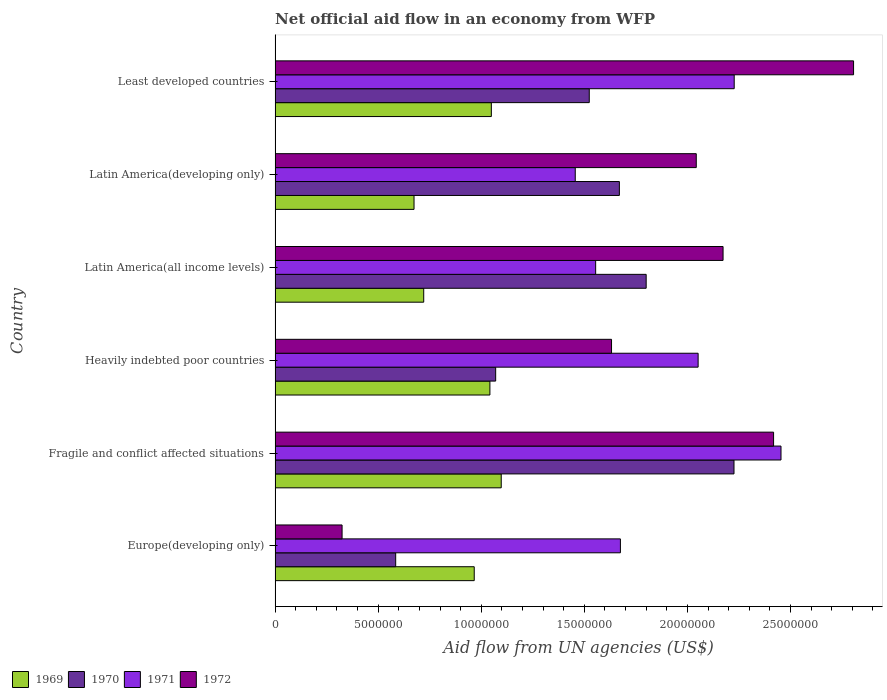How many different coloured bars are there?
Your answer should be very brief. 4. How many groups of bars are there?
Offer a terse response. 6. Are the number of bars per tick equal to the number of legend labels?
Provide a short and direct response. Yes. Are the number of bars on each tick of the Y-axis equal?
Provide a short and direct response. Yes. How many bars are there on the 3rd tick from the top?
Provide a succinct answer. 4. How many bars are there on the 2nd tick from the bottom?
Offer a very short reply. 4. What is the label of the 2nd group of bars from the top?
Make the answer very short. Latin America(developing only). What is the net official aid flow in 1970 in Latin America(developing only)?
Your response must be concise. 1.67e+07. Across all countries, what is the maximum net official aid flow in 1972?
Offer a very short reply. 2.81e+07. Across all countries, what is the minimum net official aid flow in 1970?
Ensure brevity in your answer.  5.85e+06. In which country was the net official aid flow in 1970 maximum?
Make the answer very short. Fragile and conflict affected situations. In which country was the net official aid flow in 1971 minimum?
Ensure brevity in your answer.  Latin America(developing only). What is the total net official aid flow in 1971 in the graph?
Give a very brief answer. 1.14e+08. What is the difference between the net official aid flow in 1970 in Fragile and conflict affected situations and that in Heavily indebted poor countries?
Your answer should be very brief. 1.16e+07. What is the difference between the net official aid flow in 1971 in Heavily indebted poor countries and the net official aid flow in 1972 in Latin America(all income levels)?
Your response must be concise. -1.21e+06. What is the average net official aid flow in 1971 per country?
Offer a very short reply. 1.90e+07. What is the difference between the net official aid flow in 1969 and net official aid flow in 1972 in Fragile and conflict affected situations?
Offer a terse response. -1.32e+07. In how many countries, is the net official aid flow in 1970 greater than 10000000 US$?
Keep it short and to the point. 5. What is the ratio of the net official aid flow in 1971 in Fragile and conflict affected situations to that in Least developed countries?
Your response must be concise. 1.1. Is the net official aid flow in 1970 in Europe(developing only) less than that in Latin America(developing only)?
Provide a succinct answer. Yes. What is the difference between the highest and the second highest net official aid flow in 1970?
Your answer should be compact. 4.26e+06. What is the difference between the highest and the lowest net official aid flow in 1969?
Offer a terse response. 4.23e+06. In how many countries, is the net official aid flow in 1969 greater than the average net official aid flow in 1969 taken over all countries?
Provide a short and direct response. 4. Is it the case that in every country, the sum of the net official aid flow in 1970 and net official aid flow in 1969 is greater than the sum of net official aid flow in 1972 and net official aid flow in 1971?
Make the answer very short. No. What does the 3rd bar from the bottom in Latin America(all income levels) represents?
Provide a succinct answer. 1971. How many countries are there in the graph?
Provide a short and direct response. 6. What is the difference between two consecutive major ticks on the X-axis?
Provide a short and direct response. 5.00e+06. Where does the legend appear in the graph?
Your response must be concise. Bottom left. What is the title of the graph?
Provide a short and direct response. Net official aid flow in an economy from WFP. Does "1986" appear as one of the legend labels in the graph?
Your response must be concise. No. What is the label or title of the X-axis?
Give a very brief answer. Aid flow from UN agencies (US$). What is the label or title of the Y-axis?
Keep it short and to the point. Country. What is the Aid flow from UN agencies (US$) of 1969 in Europe(developing only)?
Your answer should be compact. 9.66e+06. What is the Aid flow from UN agencies (US$) in 1970 in Europe(developing only)?
Provide a short and direct response. 5.85e+06. What is the Aid flow from UN agencies (US$) in 1971 in Europe(developing only)?
Your answer should be very brief. 1.68e+07. What is the Aid flow from UN agencies (US$) in 1972 in Europe(developing only)?
Your answer should be very brief. 3.25e+06. What is the Aid flow from UN agencies (US$) in 1969 in Fragile and conflict affected situations?
Provide a succinct answer. 1.10e+07. What is the Aid flow from UN agencies (US$) of 1970 in Fragile and conflict affected situations?
Provide a succinct answer. 2.23e+07. What is the Aid flow from UN agencies (US$) of 1971 in Fragile and conflict affected situations?
Provide a succinct answer. 2.45e+07. What is the Aid flow from UN agencies (US$) in 1972 in Fragile and conflict affected situations?
Give a very brief answer. 2.42e+07. What is the Aid flow from UN agencies (US$) of 1969 in Heavily indebted poor countries?
Offer a terse response. 1.04e+07. What is the Aid flow from UN agencies (US$) in 1970 in Heavily indebted poor countries?
Your answer should be compact. 1.07e+07. What is the Aid flow from UN agencies (US$) in 1971 in Heavily indebted poor countries?
Provide a succinct answer. 2.05e+07. What is the Aid flow from UN agencies (US$) in 1972 in Heavily indebted poor countries?
Your response must be concise. 1.63e+07. What is the Aid flow from UN agencies (US$) of 1969 in Latin America(all income levels)?
Provide a succinct answer. 7.21e+06. What is the Aid flow from UN agencies (US$) of 1970 in Latin America(all income levels)?
Your answer should be very brief. 1.80e+07. What is the Aid flow from UN agencies (US$) of 1971 in Latin America(all income levels)?
Provide a short and direct response. 1.56e+07. What is the Aid flow from UN agencies (US$) of 1972 in Latin America(all income levels)?
Your answer should be compact. 2.17e+07. What is the Aid flow from UN agencies (US$) of 1969 in Latin America(developing only)?
Give a very brief answer. 6.74e+06. What is the Aid flow from UN agencies (US$) in 1970 in Latin America(developing only)?
Your response must be concise. 1.67e+07. What is the Aid flow from UN agencies (US$) in 1971 in Latin America(developing only)?
Ensure brevity in your answer.  1.46e+07. What is the Aid flow from UN agencies (US$) in 1972 in Latin America(developing only)?
Your answer should be compact. 2.04e+07. What is the Aid flow from UN agencies (US$) in 1969 in Least developed countries?
Your response must be concise. 1.05e+07. What is the Aid flow from UN agencies (US$) of 1970 in Least developed countries?
Keep it short and to the point. 1.52e+07. What is the Aid flow from UN agencies (US$) in 1971 in Least developed countries?
Give a very brief answer. 2.23e+07. What is the Aid flow from UN agencies (US$) in 1972 in Least developed countries?
Ensure brevity in your answer.  2.81e+07. Across all countries, what is the maximum Aid flow from UN agencies (US$) in 1969?
Make the answer very short. 1.10e+07. Across all countries, what is the maximum Aid flow from UN agencies (US$) of 1970?
Your answer should be compact. 2.23e+07. Across all countries, what is the maximum Aid flow from UN agencies (US$) of 1971?
Your answer should be very brief. 2.45e+07. Across all countries, what is the maximum Aid flow from UN agencies (US$) in 1972?
Ensure brevity in your answer.  2.81e+07. Across all countries, what is the minimum Aid flow from UN agencies (US$) of 1969?
Your answer should be very brief. 6.74e+06. Across all countries, what is the minimum Aid flow from UN agencies (US$) of 1970?
Provide a succinct answer. 5.85e+06. Across all countries, what is the minimum Aid flow from UN agencies (US$) of 1971?
Ensure brevity in your answer.  1.46e+07. Across all countries, what is the minimum Aid flow from UN agencies (US$) of 1972?
Provide a short and direct response. 3.25e+06. What is the total Aid flow from UN agencies (US$) of 1969 in the graph?
Keep it short and to the point. 5.55e+07. What is the total Aid flow from UN agencies (US$) in 1970 in the graph?
Your response must be concise. 8.88e+07. What is the total Aid flow from UN agencies (US$) in 1971 in the graph?
Your answer should be very brief. 1.14e+08. What is the total Aid flow from UN agencies (US$) in 1972 in the graph?
Offer a very short reply. 1.14e+08. What is the difference between the Aid flow from UN agencies (US$) in 1969 in Europe(developing only) and that in Fragile and conflict affected situations?
Ensure brevity in your answer.  -1.31e+06. What is the difference between the Aid flow from UN agencies (US$) in 1970 in Europe(developing only) and that in Fragile and conflict affected situations?
Provide a succinct answer. -1.64e+07. What is the difference between the Aid flow from UN agencies (US$) in 1971 in Europe(developing only) and that in Fragile and conflict affected situations?
Make the answer very short. -7.79e+06. What is the difference between the Aid flow from UN agencies (US$) of 1972 in Europe(developing only) and that in Fragile and conflict affected situations?
Give a very brief answer. -2.09e+07. What is the difference between the Aid flow from UN agencies (US$) of 1969 in Europe(developing only) and that in Heavily indebted poor countries?
Your answer should be very brief. -7.60e+05. What is the difference between the Aid flow from UN agencies (US$) in 1970 in Europe(developing only) and that in Heavily indebted poor countries?
Your answer should be very brief. -4.85e+06. What is the difference between the Aid flow from UN agencies (US$) of 1971 in Europe(developing only) and that in Heavily indebted poor countries?
Offer a terse response. -3.77e+06. What is the difference between the Aid flow from UN agencies (US$) in 1972 in Europe(developing only) and that in Heavily indebted poor countries?
Offer a terse response. -1.31e+07. What is the difference between the Aid flow from UN agencies (US$) of 1969 in Europe(developing only) and that in Latin America(all income levels)?
Your answer should be very brief. 2.45e+06. What is the difference between the Aid flow from UN agencies (US$) of 1970 in Europe(developing only) and that in Latin America(all income levels)?
Offer a very short reply. -1.22e+07. What is the difference between the Aid flow from UN agencies (US$) of 1971 in Europe(developing only) and that in Latin America(all income levels)?
Provide a succinct answer. 1.20e+06. What is the difference between the Aid flow from UN agencies (US$) of 1972 in Europe(developing only) and that in Latin America(all income levels)?
Your answer should be very brief. -1.85e+07. What is the difference between the Aid flow from UN agencies (US$) in 1969 in Europe(developing only) and that in Latin America(developing only)?
Provide a succinct answer. 2.92e+06. What is the difference between the Aid flow from UN agencies (US$) of 1970 in Europe(developing only) and that in Latin America(developing only)?
Make the answer very short. -1.08e+07. What is the difference between the Aid flow from UN agencies (US$) of 1971 in Europe(developing only) and that in Latin America(developing only)?
Your answer should be very brief. 2.19e+06. What is the difference between the Aid flow from UN agencies (US$) of 1972 in Europe(developing only) and that in Latin America(developing only)?
Offer a terse response. -1.72e+07. What is the difference between the Aid flow from UN agencies (US$) of 1969 in Europe(developing only) and that in Least developed countries?
Your response must be concise. -8.30e+05. What is the difference between the Aid flow from UN agencies (US$) of 1970 in Europe(developing only) and that in Least developed countries?
Keep it short and to the point. -9.39e+06. What is the difference between the Aid flow from UN agencies (US$) in 1971 in Europe(developing only) and that in Least developed countries?
Make the answer very short. -5.52e+06. What is the difference between the Aid flow from UN agencies (US$) of 1972 in Europe(developing only) and that in Least developed countries?
Provide a short and direct response. -2.48e+07. What is the difference between the Aid flow from UN agencies (US$) in 1970 in Fragile and conflict affected situations and that in Heavily indebted poor countries?
Provide a short and direct response. 1.16e+07. What is the difference between the Aid flow from UN agencies (US$) in 1971 in Fragile and conflict affected situations and that in Heavily indebted poor countries?
Provide a short and direct response. 4.02e+06. What is the difference between the Aid flow from UN agencies (US$) in 1972 in Fragile and conflict affected situations and that in Heavily indebted poor countries?
Keep it short and to the point. 7.86e+06. What is the difference between the Aid flow from UN agencies (US$) of 1969 in Fragile and conflict affected situations and that in Latin America(all income levels)?
Provide a succinct answer. 3.76e+06. What is the difference between the Aid flow from UN agencies (US$) in 1970 in Fragile and conflict affected situations and that in Latin America(all income levels)?
Keep it short and to the point. 4.26e+06. What is the difference between the Aid flow from UN agencies (US$) in 1971 in Fragile and conflict affected situations and that in Latin America(all income levels)?
Provide a succinct answer. 8.99e+06. What is the difference between the Aid flow from UN agencies (US$) of 1972 in Fragile and conflict affected situations and that in Latin America(all income levels)?
Provide a short and direct response. 2.45e+06. What is the difference between the Aid flow from UN agencies (US$) of 1969 in Fragile and conflict affected situations and that in Latin America(developing only)?
Offer a terse response. 4.23e+06. What is the difference between the Aid flow from UN agencies (US$) in 1970 in Fragile and conflict affected situations and that in Latin America(developing only)?
Give a very brief answer. 5.56e+06. What is the difference between the Aid flow from UN agencies (US$) of 1971 in Fragile and conflict affected situations and that in Latin America(developing only)?
Your response must be concise. 9.98e+06. What is the difference between the Aid flow from UN agencies (US$) of 1972 in Fragile and conflict affected situations and that in Latin America(developing only)?
Make the answer very short. 3.75e+06. What is the difference between the Aid flow from UN agencies (US$) in 1970 in Fragile and conflict affected situations and that in Least developed countries?
Your answer should be compact. 7.02e+06. What is the difference between the Aid flow from UN agencies (US$) in 1971 in Fragile and conflict affected situations and that in Least developed countries?
Offer a very short reply. 2.27e+06. What is the difference between the Aid flow from UN agencies (US$) in 1972 in Fragile and conflict affected situations and that in Least developed countries?
Ensure brevity in your answer.  -3.88e+06. What is the difference between the Aid flow from UN agencies (US$) of 1969 in Heavily indebted poor countries and that in Latin America(all income levels)?
Provide a short and direct response. 3.21e+06. What is the difference between the Aid flow from UN agencies (US$) in 1970 in Heavily indebted poor countries and that in Latin America(all income levels)?
Provide a short and direct response. -7.30e+06. What is the difference between the Aid flow from UN agencies (US$) in 1971 in Heavily indebted poor countries and that in Latin America(all income levels)?
Your answer should be compact. 4.97e+06. What is the difference between the Aid flow from UN agencies (US$) in 1972 in Heavily indebted poor countries and that in Latin America(all income levels)?
Give a very brief answer. -5.41e+06. What is the difference between the Aid flow from UN agencies (US$) in 1969 in Heavily indebted poor countries and that in Latin America(developing only)?
Ensure brevity in your answer.  3.68e+06. What is the difference between the Aid flow from UN agencies (US$) of 1970 in Heavily indebted poor countries and that in Latin America(developing only)?
Provide a short and direct response. -6.00e+06. What is the difference between the Aid flow from UN agencies (US$) in 1971 in Heavily indebted poor countries and that in Latin America(developing only)?
Ensure brevity in your answer.  5.96e+06. What is the difference between the Aid flow from UN agencies (US$) of 1972 in Heavily indebted poor countries and that in Latin America(developing only)?
Offer a very short reply. -4.11e+06. What is the difference between the Aid flow from UN agencies (US$) of 1970 in Heavily indebted poor countries and that in Least developed countries?
Keep it short and to the point. -4.54e+06. What is the difference between the Aid flow from UN agencies (US$) in 1971 in Heavily indebted poor countries and that in Least developed countries?
Provide a succinct answer. -1.75e+06. What is the difference between the Aid flow from UN agencies (US$) in 1972 in Heavily indebted poor countries and that in Least developed countries?
Keep it short and to the point. -1.17e+07. What is the difference between the Aid flow from UN agencies (US$) in 1970 in Latin America(all income levels) and that in Latin America(developing only)?
Ensure brevity in your answer.  1.30e+06. What is the difference between the Aid flow from UN agencies (US$) of 1971 in Latin America(all income levels) and that in Latin America(developing only)?
Keep it short and to the point. 9.90e+05. What is the difference between the Aid flow from UN agencies (US$) of 1972 in Latin America(all income levels) and that in Latin America(developing only)?
Offer a very short reply. 1.30e+06. What is the difference between the Aid flow from UN agencies (US$) in 1969 in Latin America(all income levels) and that in Least developed countries?
Offer a very short reply. -3.28e+06. What is the difference between the Aid flow from UN agencies (US$) of 1970 in Latin America(all income levels) and that in Least developed countries?
Keep it short and to the point. 2.76e+06. What is the difference between the Aid flow from UN agencies (US$) of 1971 in Latin America(all income levels) and that in Least developed countries?
Your response must be concise. -6.72e+06. What is the difference between the Aid flow from UN agencies (US$) of 1972 in Latin America(all income levels) and that in Least developed countries?
Offer a terse response. -6.33e+06. What is the difference between the Aid flow from UN agencies (US$) of 1969 in Latin America(developing only) and that in Least developed countries?
Offer a very short reply. -3.75e+06. What is the difference between the Aid flow from UN agencies (US$) of 1970 in Latin America(developing only) and that in Least developed countries?
Ensure brevity in your answer.  1.46e+06. What is the difference between the Aid flow from UN agencies (US$) in 1971 in Latin America(developing only) and that in Least developed countries?
Your response must be concise. -7.71e+06. What is the difference between the Aid flow from UN agencies (US$) in 1972 in Latin America(developing only) and that in Least developed countries?
Your answer should be very brief. -7.63e+06. What is the difference between the Aid flow from UN agencies (US$) in 1969 in Europe(developing only) and the Aid flow from UN agencies (US$) in 1970 in Fragile and conflict affected situations?
Your answer should be compact. -1.26e+07. What is the difference between the Aid flow from UN agencies (US$) of 1969 in Europe(developing only) and the Aid flow from UN agencies (US$) of 1971 in Fragile and conflict affected situations?
Your answer should be very brief. -1.49e+07. What is the difference between the Aid flow from UN agencies (US$) of 1969 in Europe(developing only) and the Aid flow from UN agencies (US$) of 1972 in Fragile and conflict affected situations?
Offer a very short reply. -1.45e+07. What is the difference between the Aid flow from UN agencies (US$) in 1970 in Europe(developing only) and the Aid flow from UN agencies (US$) in 1971 in Fragile and conflict affected situations?
Keep it short and to the point. -1.87e+07. What is the difference between the Aid flow from UN agencies (US$) in 1970 in Europe(developing only) and the Aid flow from UN agencies (US$) in 1972 in Fragile and conflict affected situations?
Your answer should be very brief. -1.83e+07. What is the difference between the Aid flow from UN agencies (US$) of 1971 in Europe(developing only) and the Aid flow from UN agencies (US$) of 1972 in Fragile and conflict affected situations?
Give a very brief answer. -7.43e+06. What is the difference between the Aid flow from UN agencies (US$) in 1969 in Europe(developing only) and the Aid flow from UN agencies (US$) in 1970 in Heavily indebted poor countries?
Give a very brief answer. -1.04e+06. What is the difference between the Aid flow from UN agencies (US$) in 1969 in Europe(developing only) and the Aid flow from UN agencies (US$) in 1971 in Heavily indebted poor countries?
Your answer should be compact. -1.09e+07. What is the difference between the Aid flow from UN agencies (US$) in 1969 in Europe(developing only) and the Aid flow from UN agencies (US$) in 1972 in Heavily indebted poor countries?
Ensure brevity in your answer.  -6.66e+06. What is the difference between the Aid flow from UN agencies (US$) of 1970 in Europe(developing only) and the Aid flow from UN agencies (US$) of 1971 in Heavily indebted poor countries?
Offer a very short reply. -1.47e+07. What is the difference between the Aid flow from UN agencies (US$) of 1970 in Europe(developing only) and the Aid flow from UN agencies (US$) of 1972 in Heavily indebted poor countries?
Provide a succinct answer. -1.05e+07. What is the difference between the Aid flow from UN agencies (US$) in 1969 in Europe(developing only) and the Aid flow from UN agencies (US$) in 1970 in Latin America(all income levels)?
Your response must be concise. -8.34e+06. What is the difference between the Aid flow from UN agencies (US$) in 1969 in Europe(developing only) and the Aid flow from UN agencies (US$) in 1971 in Latin America(all income levels)?
Keep it short and to the point. -5.89e+06. What is the difference between the Aid flow from UN agencies (US$) in 1969 in Europe(developing only) and the Aid flow from UN agencies (US$) in 1972 in Latin America(all income levels)?
Ensure brevity in your answer.  -1.21e+07. What is the difference between the Aid flow from UN agencies (US$) of 1970 in Europe(developing only) and the Aid flow from UN agencies (US$) of 1971 in Latin America(all income levels)?
Keep it short and to the point. -9.70e+06. What is the difference between the Aid flow from UN agencies (US$) in 1970 in Europe(developing only) and the Aid flow from UN agencies (US$) in 1972 in Latin America(all income levels)?
Give a very brief answer. -1.59e+07. What is the difference between the Aid flow from UN agencies (US$) of 1971 in Europe(developing only) and the Aid flow from UN agencies (US$) of 1972 in Latin America(all income levels)?
Keep it short and to the point. -4.98e+06. What is the difference between the Aid flow from UN agencies (US$) in 1969 in Europe(developing only) and the Aid flow from UN agencies (US$) in 1970 in Latin America(developing only)?
Provide a short and direct response. -7.04e+06. What is the difference between the Aid flow from UN agencies (US$) in 1969 in Europe(developing only) and the Aid flow from UN agencies (US$) in 1971 in Latin America(developing only)?
Your answer should be compact. -4.90e+06. What is the difference between the Aid flow from UN agencies (US$) in 1969 in Europe(developing only) and the Aid flow from UN agencies (US$) in 1972 in Latin America(developing only)?
Your response must be concise. -1.08e+07. What is the difference between the Aid flow from UN agencies (US$) in 1970 in Europe(developing only) and the Aid flow from UN agencies (US$) in 1971 in Latin America(developing only)?
Keep it short and to the point. -8.71e+06. What is the difference between the Aid flow from UN agencies (US$) in 1970 in Europe(developing only) and the Aid flow from UN agencies (US$) in 1972 in Latin America(developing only)?
Provide a short and direct response. -1.46e+07. What is the difference between the Aid flow from UN agencies (US$) of 1971 in Europe(developing only) and the Aid flow from UN agencies (US$) of 1972 in Latin America(developing only)?
Give a very brief answer. -3.68e+06. What is the difference between the Aid flow from UN agencies (US$) in 1969 in Europe(developing only) and the Aid flow from UN agencies (US$) in 1970 in Least developed countries?
Provide a succinct answer. -5.58e+06. What is the difference between the Aid flow from UN agencies (US$) of 1969 in Europe(developing only) and the Aid flow from UN agencies (US$) of 1971 in Least developed countries?
Offer a terse response. -1.26e+07. What is the difference between the Aid flow from UN agencies (US$) in 1969 in Europe(developing only) and the Aid flow from UN agencies (US$) in 1972 in Least developed countries?
Ensure brevity in your answer.  -1.84e+07. What is the difference between the Aid flow from UN agencies (US$) of 1970 in Europe(developing only) and the Aid flow from UN agencies (US$) of 1971 in Least developed countries?
Give a very brief answer. -1.64e+07. What is the difference between the Aid flow from UN agencies (US$) of 1970 in Europe(developing only) and the Aid flow from UN agencies (US$) of 1972 in Least developed countries?
Keep it short and to the point. -2.22e+07. What is the difference between the Aid flow from UN agencies (US$) in 1971 in Europe(developing only) and the Aid flow from UN agencies (US$) in 1972 in Least developed countries?
Provide a short and direct response. -1.13e+07. What is the difference between the Aid flow from UN agencies (US$) in 1969 in Fragile and conflict affected situations and the Aid flow from UN agencies (US$) in 1971 in Heavily indebted poor countries?
Ensure brevity in your answer.  -9.55e+06. What is the difference between the Aid flow from UN agencies (US$) of 1969 in Fragile and conflict affected situations and the Aid flow from UN agencies (US$) of 1972 in Heavily indebted poor countries?
Offer a terse response. -5.35e+06. What is the difference between the Aid flow from UN agencies (US$) in 1970 in Fragile and conflict affected situations and the Aid flow from UN agencies (US$) in 1971 in Heavily indebted poor countries?
Make the answer very short. 1.74e+06. What is the difference between the Aid flow from UN agencies (US$) of 1970 in Fragile and conflict affected situations and the Aid flow from UN agencies (US$) of 1972 in Heavily indebted poor countries?
Your answer should be very brief. 5.94e+06. What is the difference between the Aid flow from UN agencies (US$) of 1971 in Fragile and conflict affected situations and the Aid flow from UN agencies (US$) of 1972 in Heavily indebted poor countries?
Keep it short and to the point. 8.22e+06. What is the difference between the Aid flow from UN agencies (US$) of 1969 in Fragile and conflict affected situations and the Aid flow from UN agencies (US$) of 1970 in Latin America(all income levels)?
Keep it short and to the point. -7.03e+06. What is the difference between the Aid flow from UN agencies (US$) in 1969 in Fragile and conflict affected situations and the Aid flow from UN agencies (US$) in 1971 in Latin America(all income levels)?
Provide a short and direct response. -4.58e+06. What is the difference between the Aid flow from UN agencies (US$) of 1969 in Fragile and conflict affected situations and the Aid flow from UN agencies (US$) of 1972 in Latin America(all income levels)?
Provide a succinct answer. -1.08e+07. What is the difference between the Aid flow from UN agencies (US$) of 1970 in Fragile and conflict affected situations and the Aid flow from UN agencies (US$) of 1971 in Latin America(all income levels)?
Offer a terse response. 6.71e+06. What is the difference between the Aid flow from UN agencies (US$) of 1970 in Fragile and conflict affected situations and the Aid flow from UN agencies (US$) of 1972 in Latin America(all income levels)?
Offer a very short reply. 5.30e+05. What is the difference between the Aid flow from UN agencies (US$) in 1971 in Fragile and conflict affected situations and the Aid flow from UN agencies (US$) in 1972 in Latin America(all income levels)?
Provide a short and direct response. 2.81e+06. What is the difference between the Aid flow from UN agencies (US$) of 1969 in Fragile and conflict affected situations and the Aid flow from UN agencies (US$) of 1970 in Latin America(developing only)?
Your response must be concise. -5.73e+06. What is the difference between the Aid flow from UN agencies (US$) of 1969 in Fragile and conflict affected situations and the Aid flow from UN agencies (US$) of 1971 in Latin America(developing only)?
Keep it short and to the point. -3.59e+06. What is the difference between the Aid flow from UN agencies (US$) in 1969 in Fragile and conflict affected situations and the Aid flow from UN agencies (US$) in 1972 in Latin America(developing only)?
Make the answer very short. -9.46e+06. What is the difference between the Aid flow from UN agencies (US$) in 1970 in Fragile and conflict affected situations and the Aid flow from UN agencies (US$) in 1971 in Latin America(developing only)?
Your response must be concise. 7.70e+06. What is the difference between the Aid flow from UN agencies (US$) in 1970 in Fragile and conflict affected situations and the Aid flow from UN agencies (US$) in 1972 in Latin America(developing only)?
Ensure brevity in your answer.  1.83e+06. What is the difference between the Aid flow from UN agencies (US$) of 1971 in Fragile and conflict affected situations and the Aid flow from UN agencies (US$) of 1972 in Latin America(developing only)?
Your answer should be very brief. 4.11e+06. What is the difference between the Aid flow from UN agencies (US$) of 1969 in Fragile and conflict affected situations and the Aid flow from UN agencies (US$) of 1970 in Least developed countries?
Your answer should be very brief. -4.27e+06. What is the difference between the Aid flow from UN agencies (US$) in 1969 in Fragile and conflict affected situations and the Aid flow from UN agencies (US$) in 1971 in Least developed countries?
Your answer should be very brief. -1.13e+07. What is the difference between the Aid flow from UN agencies (US$) in 1969 in Fragile and conflict affected situations and the Aid flow from UN agencies (US$) in 1972 in Least developed countries?
Ensure brevity in your answer.  -1.71e+07. What is the difference between the Aid flow from UN agencies (US$) of 1970 in Fragile and conflict affected situations and the Aid flow from UN agencies (US$) of 1971 in Least developed countries?
Ensure brevity in your answer.  -10000. What is the difference between the Aid flow from UN agencies (US$) in 1970 in Fragile and conflict affected situations and the Aid flow from UN agencies (US$) in 1972 in Least developed countries?
Your answer should be very brief. -5.80e+06. What is the difference between the Aid flow from UN agencies (US$) of 1971 in Fragile and conflict affected situations and the Aid flow from UN agencies (US$) of 1972 in Least developed countries?
Provide a short and direct response. -3.52e+06. What is the difference between the Aid flow from UN agencies (US$) in 1969 in Heavily indebted poor countries and the Aid flow from UN agencies (US$) in 1970 in Latin America(all income levels)?
Offer a very short reply. -7.58e+06. What is the difference between the Aid flow from UN agencies (US$) of 1969 in Heavily indebted poor countries and the Aid flow from UN agencies (US$) of 1971 in Latin America(all income levels)?
Provide a succinct answer. -5.13e+06. What is the difference between the Aid flow from UN agencies (US$) of 1969 in Heavily indebted poor countries and the Aid flow from UN agencies (US$) of 1972 in Latin America(all income levels)?
Offer a terse response. -1.13e+07. What is the difference between the Aid flow from UN agencies (US$) of 1970 in Heavily indebted poor countries and the Aid flow from UN agencies (US$) of 1971 in Latin America(all income levels)?
Provide a succinct answer. -4.85e+06. What is the difference between the Aid flow from UN agencies (US$) of 1970 in Heavily indebted poor countries and the Aid flow from UN agencies (US$) of 1972 in Latin America(all income levels)?
Your answer should be very brief. -1.10e+07. What is the difference between the Aid flow from UN agencies (US$) in 1971 in Heavily indebted poor countries and the Aid flow from UN agencies (US$) in 1972 in Latin America(all income levels)?
Provide a short and direct response. -1.21e+06. What is the difference between the Aid flow from UN agencies (US$) in 1969 in Heavily indebted poor countries and the Aid flow from UN agencies (US$) in 1970 in Latin America(developing only)?
Offer a terse response. -6.28e+06. What is the difference between the Aid flow from UN agencies (US$) in 1969 in Heavily indebted poor countries and the Aid flow from UN agencies (US$) in 1971 in Latin America(developing only)?
Make the answer very short. -4.14e+06. What is the difference between the Aid flow from UN agencies (US$) of 1969 in Heavily indebted poor countries and the Aid flow from UN agencies (US$) of 1972 in Latin America(developing only)?
Provide a short and direct response. -1.00e+07. What is the difference between the Aid flow from UN agencies (US$) of 1970 in Heavily indebted poor countries and the Aid flow from UN agencies (US$) of 1971 in Latin America(developing only)?
Your response must be concise. -3.86e+06. What is the difference between the Aid flow from UN agencies (US$) in 1970 in Heavily indebted poor countries and the Aid flow from UN agencies (US$) in 1972 in Latin America(developing only)?
Your response must be concise. -9.73e+06. What is the difference between the Aid flow from UN agencies (US$) of 1971 in Heavily indebted poor countries and the Aid flow from UN agencies (US$) of 1972 in Latin America(developing only)?
Give a very brief answer. 9.00e+04. What is the difference between the Aid flow from UN agencies (US$) of 1969 in Heavily indebted poor countries and the Aid flow from UN agencies (US$) of 1970 in Least developed countries?
Ensure brevity in your answer.  -4.82e+06. What is the difference between the Aid flow from UN agencies (US$) in 1969 in Heavily indebted poor countries and the Aid flow from UN agencies (US$) in 1971 in Least developed countries?
Ensure brevity in your answer.  -1.18e+07. What is the difference between the Aid flow from UN agencies (US$) of 1969 in Heavily indebted poor countries and the Aid flow from UN agencies (US$) of 1972 in Least developed countries?
Provide a short and direct response. -1.76e+07. What is the difference between the Aid flow from UN agencies (US$) of 1970 in Heavily indebted poor countries and the Aid flow from UN agencies (US$) of 1971 in Least developed countries?
Your answer should be compact. -1.16e+07. What is the difference between the Aid flow from UN agencies (US$) in 1970 in Heavily indebted poor countries and the Aid flow from UN agencies (US$) in 1972 in Least developed countries?
Your answer should be compact. -1.74e+07. What is the difference between the Aid flow from UN agencies (US$) of 1971 in Heavily indebted poor countries and the Aid flow from UN agencies (US$) of 1972 in Least developed countries?
Provide a short and direct response. -7.54e+06. What is the difference between the Aid flow from UN agencies (US$) of 1969 in Latin America(all income levels) and the Aid flow from UN agencies (US$) of 1970 in Latin America(developing only)?
Give a very brief answer. -9.49e+06. What is the difference between the Aid flow from UN agencies (US$) of 1969 in Latin America(all income levels) and the Aid flow from UN agencies (US$) of 1971 in Latin America(developing only)?
Keep it short and to the point. -7.35e+06. What is the difference between the Aid flow from UN agencies (US$) in 1969 in Latin America(all income levels) and the Aid flow from UN agencies (US$) in 1972 in Latin America(developing only)?
Ensure brevity in your answer.  -1.32e+07. What is the difference between the Aid flow from UN agencies (US$) of 1970 in Latin America(all income levels) and the Aid flow from UN agencies (US$) of 1971 in Latin America(developing only)?
Make the answer very short. 3.44e+06. What is the difference between the Aid flow from UN agencies (US$) of 1970 in Latin America(all income levels) and the Aid flow from UN agencies (US$) of 1972 in Latin America(developing only)?
Offer a very short reply. -2.43e+06. What is the difference between the Aid flow from UN agencies (US$) in 1971 in Latin America(all income levels) and the Aid flow from UN agencies (US$) in 1972 in Latin America(developing only)?
Your answer should be very brief. -4.88e+06. What is the difference between the Aid flow from UN agencies (US$) in 1969 in Latin America(all income levels) and the Aid flow from UN agencies (US$) in 1970 in Least developed countries?
Offer a terse response. -8.03e+06. What is the difference between the Aid flow from UN agencies (US$) in 1969 in Latin America(all income levels) and the Aid flow from UN agencies (US$) in 1971 in Least developed countries?
Your answer should be compact. -1.51e+07. What is the difference between the Aid flow from UN agencies (US$) in 1969 in Latin America(all income levels) and the Aid flow from UN agencies (US$) in 1972 in Least developed countries?
Provide a short and direct response. -2.08e+07. What is the difference between the Aid flow from UN agencies (US$) in 1970 in Latin America(all income levels) and the Aid flow from UN agencies (US$) in 1971 in Least developed countries?
Give a very brief answer. -4.27e+06. What is the difference between the Aid flow from UN agencies (US$) of 1970 in Latin America(all income levels) and the Aid flow from UN agencies (US$) of 1972 in Least developed countries?
Offer a terse response. -1.01e+07. What is the difference between the Aid flow from UN agencies (US$) in 1971 in Latin America(all income levels) and the Aid flow from UN agencies (US$) in 1972 in Least developed countries?
Offer a very short reply. -1.25e+07. What is the difference between the Aid flow from UN agencies (US$) of 1969 in Latin America(developing only) and the Aid flow from UN agencies (US$) of 1970 in Least developed countries?
Your answer should be very brief. -8.50e+06. What is the difference between the Aid flow from UN agencies (US$) of 1969 in Latin America(developing only) and the Aid flow from UN agencies (US$) of 1971 in Least developed countries?
Keep it short and to the point. -1.55e+07. What is the difference between the Aid flow from UN agencies (US$) of 1969 in Latin America(developing only) and the Aid flow from UN agencies (US$) of 1972 in Least developed countries?
Your answer should be compact. -2.13e+07. What is the difference between the Aid flow from UN agencies (US$) of 1970 in Latin America(developing only) and the Aid flow from UN agencies (US$) of 1971 in Least developed countries?
Ensure brevity in your answer.  -5.57e+06. What is the difference between the Aid flow from UN agencies (US$) in 1970 in Latin America(developing only) and the Aid flow from UN agencies (US$) in 1972 in Least developed countries?
Give a very brief answer. -1.14e+07. What is the difference between the Aid flow from UN agencies (US$) of 1971 in Latin America(developing only) and the Aid flow from UN agencies (US$) of 1972 in Least developed countries?
Provide a succinct answer. -1.35e+07. What is the average Aid flow from UN agencies (US$) in 1969 per country?
Ensure brevity in your answer.  9.25e+06. What is the average Aid flow from UN agencies (US$) of 1970 per country?
Keep it short and to the point. 1.48e+07. What is the average Aid flow from UN agencies (US$) in 1971 per country?
Make the answer very short. 1.90e+07. What is the average Aid flow from UN agencies (US$) of 1972 per country?
Give a very brief answer. 1.90e+07. What is the difference between the Aid flow from UN agencies (US$) of 1969 and Aid flow from UN agencies (US$) of 1970 in Europe(developing only)?
Your answer should be very brief. 3.81e+06. What is the difference between the Aid flow from UN agencies (US$) in 1969 and Aid flow from UN agencies (US$) in 1971 in Europe(developing only)?
Your answer should be compact. -7.09e+06. What is the difference between the Aid flow from UN agencies (US$) of 1969 and Aid flow from UN agencies (US$) of 1972 in Europe(developing only)?
Provide a succinct answer. 6.41e+06. What is the difference between the Aid flow from UN agencies (US$) in 1970 and Aid flow from UN agencies (US$) in 1971 in Europe(developing only)?
Provide a succinct answer. -1.09e+07. What is the difference between the Aid flow from UN agencies (US$) of 1970 and Aid flow from UN agencies (US$) of 1972 in Europe(developing only)?
Ensure brevity in your answer.  2.60e+06. What is the difference between the Aid flow from UN agencies (US$) in 1971 and Aid flow from UN agencies (US$) in 1972 in Europe(developing only)?
Keep it short and to the point. 1.35e+07. What is the difference between the Aid flow from UN agencies (US$) in 1969 and Aid flow from UN agencies (US$) in 1970 in Fragile and conflict affected situations?
Your answer should be compact. -1.13e+07. What is the difference between the Aid flow from UN agencies (US$) of 1969 and Aid flow from UN agencies (US$) of 1971 in Fragile and conflict affected situations?
Ensure brevity in your answer.  -1.36e+07. What is the difference between the Aid flow from UN agencies (US$) in 1969 and Aid flow from UN agencies (US$) in 1972 in Fragile and conflict affected situations?
Give a very brief answer. -1.32e+07. What is the difference between the Aid flow from UN agencies (US$) of 1970 and Aid flow from UN agencies (US$) of 1971 in Fragile and conflict affected situations?
Ensure brevity in your answer.  -2.28e+06. What is the difference between the Aid flow from UN agencies (US$) in 1970 and Aid flow from UN agencies (US$) in 1972 in Fragile and conflict affected situations?
Provide a short and direct response. -1.92e+06. What is the difference between the Aid flow from UN agencies (US$) of 1969 and Aid flow from UN agencies (US$) of 1970 in Heavily indebted poor countries?
Offer a terse response. -2.80e+05. What is the difference between the Aid flow from UN agencies (US$) of 1969 and Aid flow from UN agencies (US$) of 1971 in Heavily indebted poor countries?
Keep it short and to the point. -1.01e+07. What is the difference between the Aid flow from UN agencies (US$) in 1969 and Aid flow from UN agencies (US$) in 1972 in Heavily indebted poor countries?
Offer a very short reply. -5.90e+06. What is the difference between the Aid flow from UN agencies (US$) of 1970 and Aid flow from UN agencies (US$) of 1971 in Heavily indebted poor countries?
Your answer should be compact. -9.82e+06. What is the difference between the Aid flow from UN agencies (US$) in 1970 and Aid flow from UN agencies (US$) in 1972 in Heavily indebted poor countries?
Provide a short and direct response. -5.62e+06. What is the difference between the Aid flow from UN agencies (US$) of 1971 and Aid flow from UN agencies (US$) of 1972 in Heavily indebted poor countries?
Your response must be concise. 4.20e+06. What is the difference between the Aid flow from UN agencies (US$) in 1969 and Aid flow from UN agencies (US$) in 1970 in Latin America(all income levels)?
Provide a short and direct response. -1.08e+07. What is the difference between the Aid flow from UN agencies (US$) in 1969 and Aid flow from UN agencies (US$) in 1971 in Latin America(all income levels)?
Provide a succinct answer. -8.34e+06. What is the difference between the Aid flow from UN agencies (US$) of 1969 and Aid flow from UN agencies (US$) of 1972 in Latin America(all income levels)?
Offer a very short reply. -1.45e+07. What is the difference between the Aid flow from UN agencies (US$) in 1970 and Aid flow from UN agencies (US$) in 1971 in Latin America(all income levels)?
Give a very brief answer. 2.45e+06. What is the difference between the Aid flow from UN agencies (US$) of 1970 and Aid flow from UN agencies (US$) of 1972 in Latin America(all income levels)?
Make the answer very short. -3.73e+06. What is the difference between the Aid flow from UN agencies (US$) of 1971 and Aid flow from UN agencies (US$) of 1972 in Latin America(all income levels)?
Ensure brevity in your answer.  -6.18e+06. What is the difference between the Aid flow from UN agencies (US$) in 1969 and Aid flow from UN agencies (US$) in 1970 in Latin America(developing only)?
Your answer should be very brief. -9.96e+06. What is the difference between the Aid flow from UN agencies (US$) in 1969 and Aid flow from UN agencies (US$) in 1971 in Latin America(developing only)?
Make the answer very short. -7.82e+06. What is the difference between the Aid flow from UN agencies (US$) of 1969 and Aid flow from UN agencies (US$) of 1972 in Latin America(developing only)?
Give a very brief answer. -1.37e+07. What is the difference between the Aid flow from UN agencies (US$) of 1970 and Aid flow from UN agencies (US$) of 1971 in Latin America(developing only)?
Your answer should be compact. 2.14e+06. What is the difference between the Aid flow from UN agencies (US$) in 1970 and Aid flow from UN agencies (US$) in 1972 in Latin America(developing only)?
Your answer should be very brief. -3.73e+06. What is the difference between the Aid flow from UN agencies (US$) of 1971 and Aid flow from UN agencies (US$) of 1972 in Latin America(developing only)?
Keep it short and to the point. -5.87e+06. What is the difference between the Aid flow from UN agencies (US$) of 1969 and Aid flow from UN agencies (US$) of 1970 in Least developed countries?
Ensure brevity in your answer.  -4.75e+06. What is the difference between the Aid flow from UN agencies (US$) in 1969 and Aid flow from UN agencies (US$) in 1971 in Least developed countries?
Make the answer very short. -1.18e+07. What is the difference between the Aid flow from UN agencies (US$) in 1969 and Aid flow from UN agencies (US$) in 1972 in Least developed countries?
Your answer should be very brief. -1.76e+07. What is the difference between the Aid flow from UN agencies (US$) of 1970 and Aid flow from UN agencies (US$) of 1971 in Least developed countries?
Provide a succinct answer. -7.03e+06. What is the difference between the Aid flow from UN agencies (US$) of 1970 and Aid flow from UN agencies (US$) of 1972 in Least developed countries?
Provide a short and direct response. -1.28e+07. What is the difference between the Aid flow from UN agencies (US$) in 1971 and Aid flow from UN agencies (US$) in 1972 in Least developed countries?
Offer a terse response. -5.79e+06. What is the ratio of the Aid flow from UN agencies (US$) in 1969 in Europe(developing only) to that in Fragile and conflict affected situations?
Offer a very short reply. 0.88. What is the ratio of the Aid flow from UN agencies (US$) in 1970 in Europe(developing only) to that in Fragile and conflict affected situations?
Provide a succinct answer. 0.26. What is the ratio of the Aid flow from UN agencies (US$) in 1971 in Europe(developing only) to that in Fragile and conflict affected situations?
Ensure brevity in your answer.  0.68. What is the ratio of the Aid flow from UN agencies (US$) in 1972 in Europe(developing only) to that in Fragile and conflict affected situations?
Your answer should be compact. 0.13. What is the ratio of the Aid flow from UN agencies (US$) in 1969 in Europe(developing only) to that in Heavily indebted poor countries?
Your response must be concise. 0.93. What is the ratio of the Aid flow from UN agencies (US$) of 1970 in Europe(developing only) to that in Heavily indebted poor countries?
Give a very brief answer. 0.55. What is the ratio of the Aid flow from UN agencies (US$) of 1971 in Europe(developing only) to that in Heavily indebted poor countries?
Provide a succinct answer. 0.82. What is the ratio of the Aid flow from UN agencies (US$) in 1972 in Europe(developing only) to that in Heavily indebted poor countries?
Make the answer very short. 0.2. What is the ratio of the Aid flow from UN agencies (US$) of 1969 in Europe(developing only) to that in Latin America(all income levels)?
Provide a short and direct response. 1.34. What is the ratio of the Aid flow from UN agencies (US$) in 1970 in Europe(developing only) to that in Latin America(all income levels)?
Keep it short and to the point. 0.33. What is the ratio of the Aid flow from UN agencies (US$) in 1971 in Europe(developing only) to that in Latin America(all income levels)?
Give a very brief answer. 1.08. What is the ratio of the Aid flow from UN agencies (US$) in 1972 in Europe(developing only) to that in Latin America(all income levels)?
Ensure brevity in your answer.  0.15. What is the ratio of the Aid flow from UN agencies (US$) of 1969 in Europe(developing only) to that in Latin America(developing only)?
Your answer should be compact. 1.43. What is the ratio of the Aid flow from UN agencies (US$) in 1970 in Europe(developing only) to that in Latin America(developing only)?
Provide a short and direct response. 0.35. What is the ratio of the Aid flow from UN agencies (US$) in 1971 in Europe(developing only) to that in Latin America(developing only)?
Offer a very short reply. 1.15. What is the ratio of the Aid flow from UN agencies (US$) of 1972 in Europe(developing only) to that in Latin America(developing only)?
Keep it short and to the point. 0.16. What is the ratio of the Aid flow from UN agencies (US$) in 1969 in Europe(developing only) to that in Least developed countries?
Your answer should be compact. 0.92. What is the ratio of the Aid flow from UN agencies (US$) in 1970 in Europe(developing only) to that in Least developed countries?
Keep it short and to the point. 0.38. What is the ratio of the Aid flow from UN agencies (US$) of 1971 in Europe(developing only) to that in Least developed countries?
Your answer should be very brief. 0.75. What is the ratio of the Aid flow from UN agencies (US$) in 1972 in Europe(developing only) to that in Least developed countries?
Offer a very short reply. 0.12. What is the ratio of the Aid flow from UN agencies (US$) of 1969 in Fragile and conflict affected situations to that in Heavily indebted poor countries?
Give a very brief answer. 1.05. What is the ratio of the Aid flow from UN agencies (US$) of 1970 in Fragile and conflict affected situations to that in Heavily indebted poor countries?
Offer a terse response. 2.08. What is the ratio of the Aid flow from UN agencies (US$) in 1971 in Fragile and conflict affected situations to that in Heavily indebted poor countries?
Ensure brevity in your answer.  1.2. What is the ratio of the Aid flow from UN agencies (US$) of 1972 in Fragile and conflict affected situations to that in Heavily indebted poor countries?
Provide a short and direct response. 1.48. What is the ratio of the Aid flow from UN agencies (US$) in 1969 in Fragile and conflict affected situations to that in Latin America(all income levels)?
Your answer should be very brief. 1.52. What is the ratio of the Aid flow from UN agencies (US$) in 1970 in Fragile and conflict affected situations to that in Latin America(all income levels)?
Provide a succinct answer. 1.24. What is the ratio of the Aid flow from UN agencies (US$) of 1971 in Fragile and conflict affected situations to that in Latin America(all income levels)?
Keep it short and to the point. 1.58. What is the ratio of the Aid flow from UN agencies (US$) of 1972 in Fragile and conflict affected situations to that in Latin America(all income levels)?
Give a very brief answer. 1.11. What is the ratio of the Aid flow from UN agencies (US$) in 1969 in Fragile and conflict affected situations to that in Latin America(developing only)?
Your answer should be compact. 1.63. What is the ratio of the Aid flow from UN agencies (US$) in 1970 in Fragile and conflict affected situations to that in Latin America(developing only)?
Offer a terse response. 1.33. What is the ratio of the Aid flow from UN agencies (US$) of 1971 in Fragile and conflict affected situations to that in Latin America(developing only)?
Offer a terse response. 1.69. What is the ratio of the Aid flow from UN agencies (US$) of 1972 in Fragile and conflict affected situations to that in Latin America(developing only)?
Offer a very short reply. 1.18. What is the ratio of the Aid flow from UN agencies (US$) of 1969 in Fragile and conflict affected situations to that in Least developed countries?
Offer a very short reply. 1.05. What is the ratio of the Aid flow from UN agencies (US$) of 1970 in Fragile and conflict affected situations to that in Least developed countries?
Provide a succinct answer. 1.46. What is the ratio of the Aid flow from UN agencies (US$) of 1971 in Fragile and conflict affected situations to that in Least developed countries?
Keep it short and to the point. 1.1. What is the ratio of the Aid flow from UN agencies (US$) in 1972 in Fragile and conflict affected situations to that in Least developed countries?
Your answer should be compact. 0.86. What is the ratio of the Aid flow from UN agencies (US$) of 1969 in Heavily indebted poor countries to that in Latin America(all income levels)?
Your response must be concise. 1.45. What is the ratio of the Aid flow from UN agencies (US$) of 1970 in Heavily indebted poor countries to that in Latin America(all income levels)?
Make the answer very short. 0.59. What is the ratio of the Aid flow from UN agencies (US$) in 1971 in Heavily indebted poor countries to that in Latin America(all income levels)?
Your answer should be compact. 1.32. What is the ratio of the Aid flow from UN agencies (US$) in 1972 in Heavily indebted poor countries to that in Latin America(all income levels)?
Your answer should be compact. 0.75. What is the ratio of the Aid flow from UN agencies (US$) of 1969 in Heavily indebted poor countries to that in Latin America(developing only)?
Make the answer very short. 1.55. What is the ratio of the Aid flow from UN agencies (US$) of 1970 in Heavily indebted poor countries to that in Latin America(developing only)?
Offer a terse response. 0.64. What is the ratio of the Aid flow from UN agencies (US$) of 1971 in Heavily indebted poor countries to that in Latin America(developing only)?
Keep it short and to the point. 1.41. What is the ratio of the Aid flow from UN agencies (US$) of 1972 in Heavily indebted poor countries to that in Latin America(developing only)?
Your response must be concise. 0.8. What is the ratio of the Aid flow from UN agencies (US$) in 1969 in Heavily indebted poor countries to that in Least developed countries?
Give a very brief answer. 0.99. What is the ratio of the Aid flow from UN agencies (US$) in 1970 in Heavily indebted poor countries to that in Least developed countries?
Offer a very short reply. 0.7. What is the ratio of the Aid flow from UN agencies (US$) of 1971 in Heavily indebted poor countries to that in Least developed countries?
Provide a short and direct response. 0.92. What is the ratio of the Aid flow from UN agencies (US$) in 1972 in Heavily indebted poor countries to that in Least developed countries?
Make the answer very short. 0.58. What is the ratio of the Aid flow from UN agencies (US$) of 1969 in Latin America(all income levels) to that in Latin America(developing only)?
Provide a short and direct response. 1.07. What is the ratio of the Aid flow from UN agencies (US$) in 1970 in Latin America(all income levels) to that in Latin America(developing only)?
Your answer should be very brief. 1.08. What is the ratio of the Aid flow from UN agencies (US$) of 1971 in Latin America(all income levels) to that in Latin America(developing only)?
Provide a short and direct response. 1.07. What is the ratio of the Aid flow from UN agencies (US$) in 1972 in Latin America(all income levels) to that in Latin America(developing only)?
Your answer should be compact. 1.06. What is the ratio of the Aid flow from UN agencies (US$) of 1969 in Latin America(all income levels) to that in Least developed countries?
Give a very brief answer. 0.69. What is the ratio of the Aid flow from UN agencies (US$) of 1970 in Latin America(all income levels) to that in Least developed countries?
Make the answer very short. 1.18. What is the ratio of the Aid flow from UN agencies (US$) in 1971 in Latin America(all income levels) to that in Least developed countries?
Ensure brevity in your answer.  0.7. What is the ratio of the Aid flow from UN agencies (US$) of 1972 in Latin America(all income levels) to that in Least developed countries?
Your answer should be compact. 0.77. What is the ratio of the Aid flow from UN agencies (US$) in 1969 in Latin America(developing only) to that in Least developed countries?
Offer a terse response. 0.64. What is the ratio of the Aid flow from UN agencies (US$) of 1970 in Latin America(developing only) to that in Least developed countries?
Provide a succinct answer. 1.1. What is the ratio of the Aid flow from UN agencies (US$) in 1971 in Latin America(developing only) to that in Least developed countries?
Provide a succinct answer. 0.65. What is the ratio of the Aid flow from UN agencies (US$) in 1972 in Latin America(developing only) to that in Least developed countries?
Your answer should be compact. 0.73. What is the difference between the highest and the second highest Aid flow from UN agencies (US$) in 1970?
Provide a succinct answer. 4.26e+06. What is the difference between the highest and the second highest Aid flow from UN agencies (US$) in 1971?
Ensure brevity in your answer.  2.27e+06. What is the difference between the highest and the second highest Aid flow from UN agencies (US$) in 1972?
Your answer should be very brief. 3.88e+06. What is the difference between the highest and the lowest Aid flow from UN agencies (US$) in 1969?
Your answer should be very brief. 4.23e+06. What is the difference between the highest and the lowest Aid flow from UN agencies (US$) of 1970?
Keep it short and to the point. 1.64e+07. What is the difference between the highest and the lowest Aid flow from UN agencies (US$) of 1971?
Offer a terse response. 9.98e+06. What is the difference between the highest and the lowest Aid flow from UN agencies (US$) in 1972?
Keep it short and to the point. 2.48e+07. 